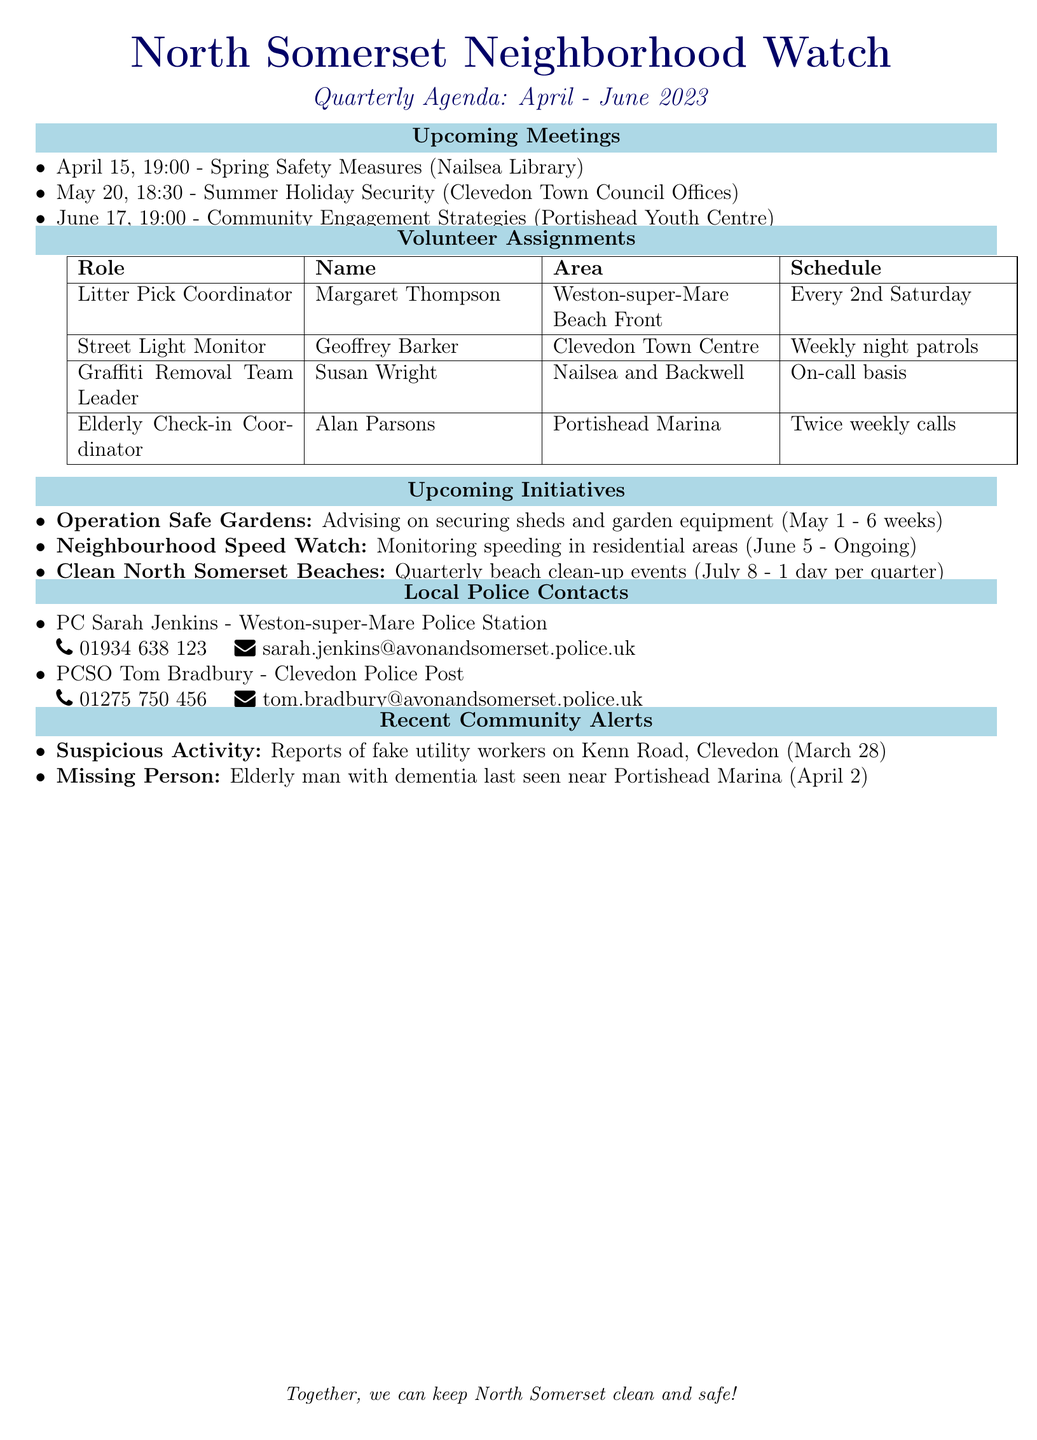What is the date of the first meeting? The first meeting is scheduled for April 15, 2023.
Answer: April 15, 2023 Who is the Litter Pick Coordinator? The Litter Pick Coordinator is listed as Margaret Thompson.
Answer: Margaret Thompson How often does the Street Light Monitor perform duties? The Street Light Monitor conducts duties on a weekly basis.
Answer: Weekly What is the location of the second meeting? The second meeting will take place at Clevedon Town Council Offices.
Answer: Clevedon Town Council Offices What is the duration of the Operation Safe Gardens initiative? The duration of the Operation Safe Gardens initiative is specified as 6 weeks.
Answer: 6 weeks Which area is Alan Parsons responsible for? Alan Parsons is responsible for the Portishead Marina area.
Answer: Portishead Marina When does the Clean North Somerset Beaches event start? The Clean North Somerset Beaches event is scheduled to start on July 8, 2023.
Answer: July 8, 2023 What is the phone number for PC Sarah Jenkins? PC Sarah Jenkins’ phone number is provided in the document as 01934 638 123.
Answer: 01934 638 123 What type of alerts are mentioned in the document? The alerts mentioned include suspicious activity and a missing person.
Answer: Suspicious Activity, Missing Person 